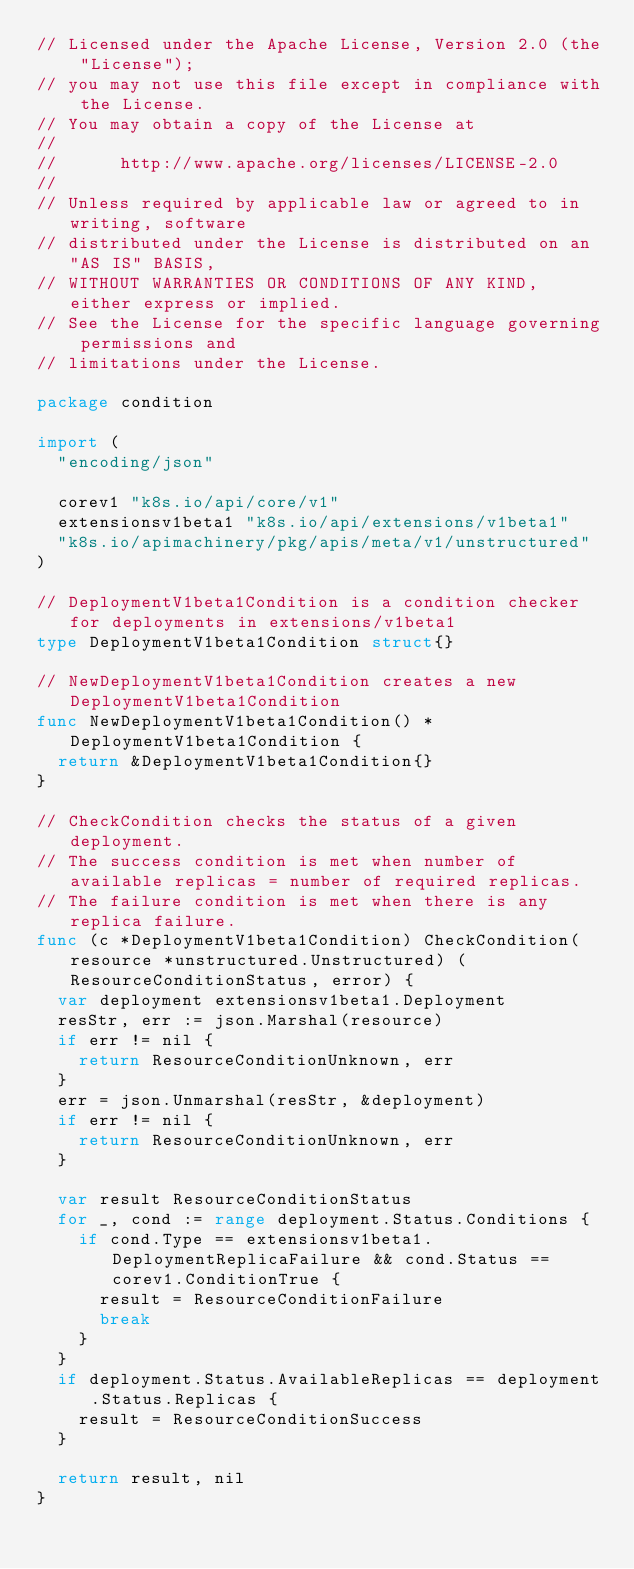<code> <loc_0><loc_0><loc_500><loc_500><_Go_>// Licensed under the Apache License, Version 2.0 (the "License");
// you may not use this file except in compliance with the License.
// You may obtain a copy of the License at
//
//      http://www.apache.org/licenses/LICENSE-2.0
//
// Unless required by applicable law or agreed to in writing, software
// distributed under the License is distributed on an "AS IS" BASIS,
// WITHOUT WARRANTIES OR CONDITIONS OF ANY KIND, either express or implied.
// See the License for the specific language governing permissions and
// limitations under the License.

package condition

import (
	"encoding/json"

	corev1 "k8s.io/api/core/v1"
	extensionsv1beta1 "k8s.io/api/extensions/v1beta1"
	"k8s.io/apimachinery/pkg/apis/meta/v1/unstructured"
)

// DeploymentV1beta1Condition is a condition checker for deployments in extensions/v1beta1
type DeploymentV1beta1Condition struct{}

// NewDeploymentV1beta1Condition creates a new DeploymentV1beta1Condition
func NewDeploymentV1beta1Condition() *DeploymentV1beta1Condition {
	return &DeploymentV1beta1Condition{}
}

// CheckCondition checks the status of a given deployment.
// The success condition is met when number of available replicas = number of required replicas.
// The failure condition is met when there is any replica failure.
func (c *DeploymentV1beta1Condition) CheckCondition(resource *unstructured.Unstructured) (ResourceConditionStatus, error) {
	var deployment extensionsv1beta1.Deployment
	resStr, err := json.Marshal(resource)
	if err != nil {
		return ResourceConditionUnknown, err
	}
	err = json.Unmarshal(resStr, &deployment)
	if err != nil {
		return ResourceConditionUnknown, err
	}

	var result ResourceConditionStatus
	for _, cond := range deployment.Status.Conditions {
		if cond.Type == extensionsv1beta1.DeploymentReplicaFailure && cond.Status == corev1.ConditionTrue {
			result = ResourceConditionFailure
			break
		}
	}
	if deployment.Status.AvailableReplicas == deployment.Status.Replicas {
		result = ResourceConditionSuccess
	}

	return result, nil
}
</code> 